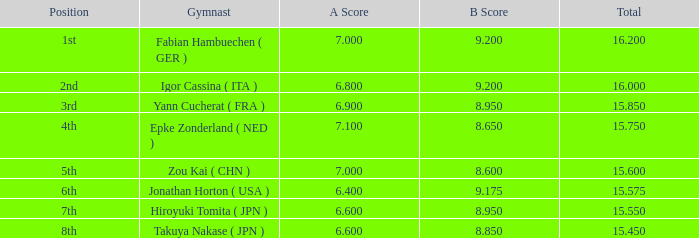What was the cumulative rating for scores above 7 and b scores below 8.65? None. 